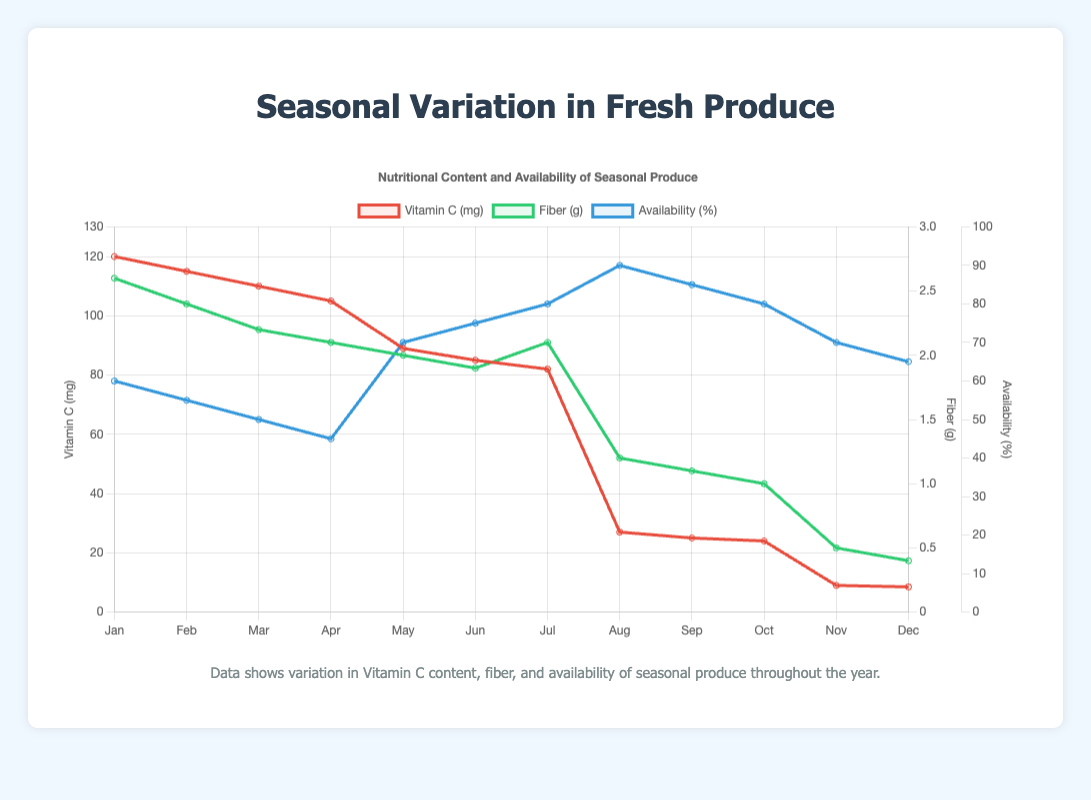What is the trend in vitamin C content from January to December? The vitamin C content shows a downward trend throughout the year, starting high in January with Kale and gradually decreasing, with the lowest content in December with Pumpkin.
Answer: Downward trend Which produce had the highest fiber content, and in which month? By examining the fiber data, the highest fiber content is found in Kale during January at 2.6 grams.
Answer: Kale in January During which month did strawberries have the highest availability? The availability data shows that strawberries had the highest availability in July with 80%.
Answer: July Compare the availability of tomatoes in August and October. Which month had higher availability? By looking at the availability data for tomatoes, August had a higher availability (90%) compared to October (80%).
Answer: August What is the difference in vitamin C content between Kale in January and Pumpkin in November? The vitamin C content in Kale in January is 120 mg, and in Pumpkin in November is 9 mg. The difference is 120 - 9 = 111 mg.
Answer: 111 mg What visual element represents the fiber content data? The fiber content data is represented by a green line on the chart.
Answer: Green line What is the total availability percentage of all produce in June? The availability in June is 75%, so the total availability percentage of all produce in June is simply 75%.
Answer: 75% Is the fiber content between May and July increasing, decreasing, or fluctuating? From May (2.0 g) and June (1.9 g) to July (2.1 g), the fiber content first decreases and then increases, indicating a fluctuating trend.
Answer: Fluctuating trend How does the vitamin C content of tomatoes in September compare to October? The vitamin C content in tomatoes in September is 25 mg, while in October it is 24 mg. Thus, September has a slightly higher vitamin C content than October.
Answer: Higher in September Calculate the average fiber content for all produce available in October. The fiber content for October is 1.0 g for tomatoes. Since only tomatoes are considered for October, the average is simply 1.0 g.
Answer: 1.0 g 